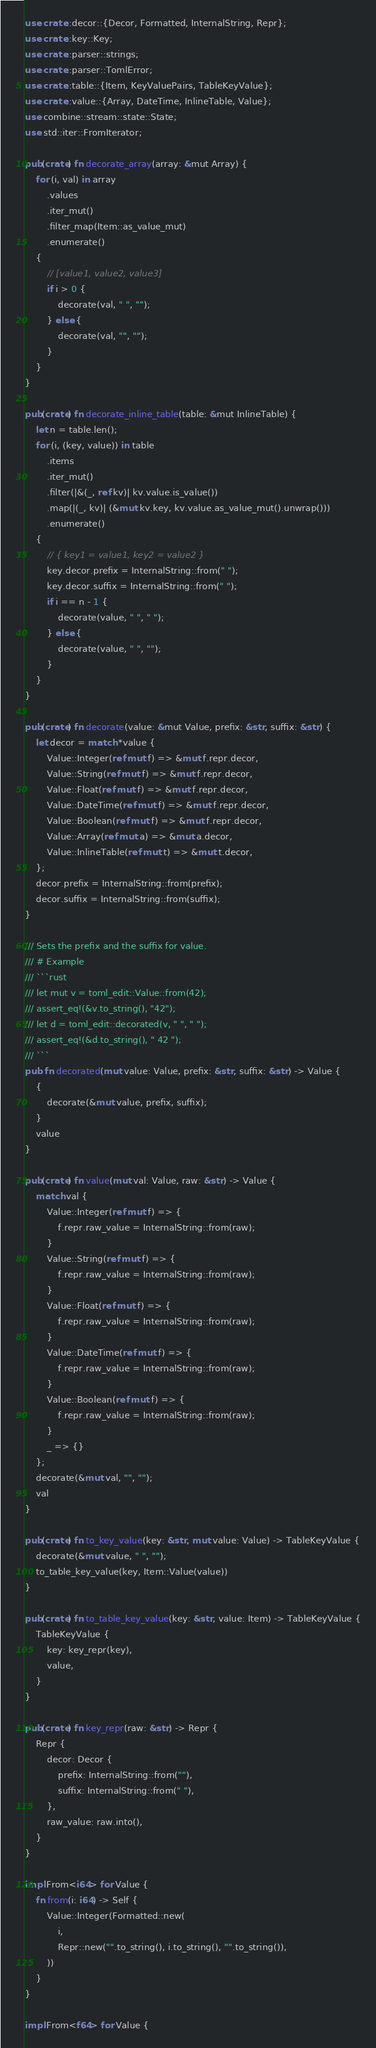<code> <loc_0><loc_0><loc_500><loc_500><_Rust_>use crate::decor::{Decor, Formatted, InternalString, Repr};
use crate::key::Key;
use crate::parser::strings;
use crate::parser::TomlError;
use crate::table::{Item, KeyValuePairs, TableKeyValue};
use crate::value::{Array, DateTime, InlineTable, Value};
use combine::stream::state::State;
use std::iter::FromIterator;

pub(crate) fn decorate_array(array: &mut Array) {
    for (i, val) in array
        .values
        .iter_mut()
        .filter_map(Item::as_value_mut)
        .enumerate()
    {
        // [value1, value2, value3]
        if i > 0 {
            decorate(val, " ", "");
        } else {
            decorate(val, "", "");
        }
    }
}

pub(crate) fn decorate_inline_table(table: &mut InlineTable) {
    let n = table.len();
    for (i, (key, value)) in table
        .items
        .iter_mut()
        .filter(|&(_, ref kv)| kv.value.is_value())
        .map(|(_, kv)| (&mut kv.key, kv.value.as_value_mut().unwrap()))
        .enumerate()
    {
        // { key1 = value1, key2 = value2 }
        key.decor.prefix = InternalString::from(" ");
        key.decor.suffix = InternalString::from(" ");
        if i == n - 1 {
            decorate(value, " ", " ");
        } else {
            decorate(value, " ", "");
        }
    }
}

pub(crate) fn decorate(value: &mut Value, prefix: &str, suffix: &str) {
    let decor = match *value {
        Value::Integer(ref mut f) => &mut f.repr.decor,
        Value::String(ref mut f) => &mut f.repr.decor,
        Value::Float(ref mut f) => &mut f.repr.decor,
        Value::DateTime(ref mut f) => &mut f.repr.decor,
        Value::Boolean(ref mut f) => &mut f.repr.decor,
        Value::Array(ref mut a) => &mut a.decor,
        Value::InlineTable(ref mut t) => &mut t.decor,
    };
    decor.prefix = InternalString::from(prefix);
    decor.suffix = InternalString::from(suffix);
}

/// Sets the prefix and the suffix for value.
/// # Example
/// ```rust
/// let mut v = toml_edit::Value::from(42);
/// assert_eq!(&v.to_string(), "42");
/// let d = toml_edit::decorated(v, " ", " ");
/// assert_eq!(&d.to_string(), " 42 ");
/// ```
pub fn decorated(mut value: Value, prefix: &str, suffix: &str) -> Value {
    {
        decorate(&mut value, prefix, suffix);
    }
    value
}

pub(crate) fn value(mut val: Value, raw: &str) -> Value {
    match val {
        Value::Integer(ref mut f) => {
            f.repr.raw_value = InternalString::from(raw);
        }
        Value::String(ref mut f) => {
            f.repr.raw_value = InternalString::from(raw);
        }
        Value::Float(ref mut f) => {
            f.repr.raw_value = InternalString::from(raw);
        }
        Value::DateTime(ref mut f) => {
            f.repr.raw_value = InternalString::from(raw);
        }
        Value::Boolean(ref mut f) => {
            f.repr.raw_value = InternalString::from(raw);
        }
        _ => {}
    };
    decorate(&mut val, "", "");
    val
}

pub(crate) fn to_key_value(key: &str, mut value: Value) -> TableKeyValue {
    decorate(&mut value, " ", "");
    to_table_key_value(key, Item::Value(value))
}

pub(crate) fn to_table_key_value(key: &str, value: Item) -> TableKeyValue {
    TableKeyValue {
        key: key_repr(key),
        value,
    }
}

pub(crate) fn key_repr(raw: &str) -> Repr {
    Repr {
        decor: Decor {
            prefix: InternalString::from(""),
            suffix: InternalString::from(" "),
        },
        raw_value: raw.into(),
    }
}

impl From<i64> for Value {
    fn from(i: i64) -> Self {
        Value::Integer(Formatted::new(
            i,
            Repr::new("".to_string(), i.to_string(), "".to_string()),
        ))
    }
}

impl From<f64> for Value {</code> 